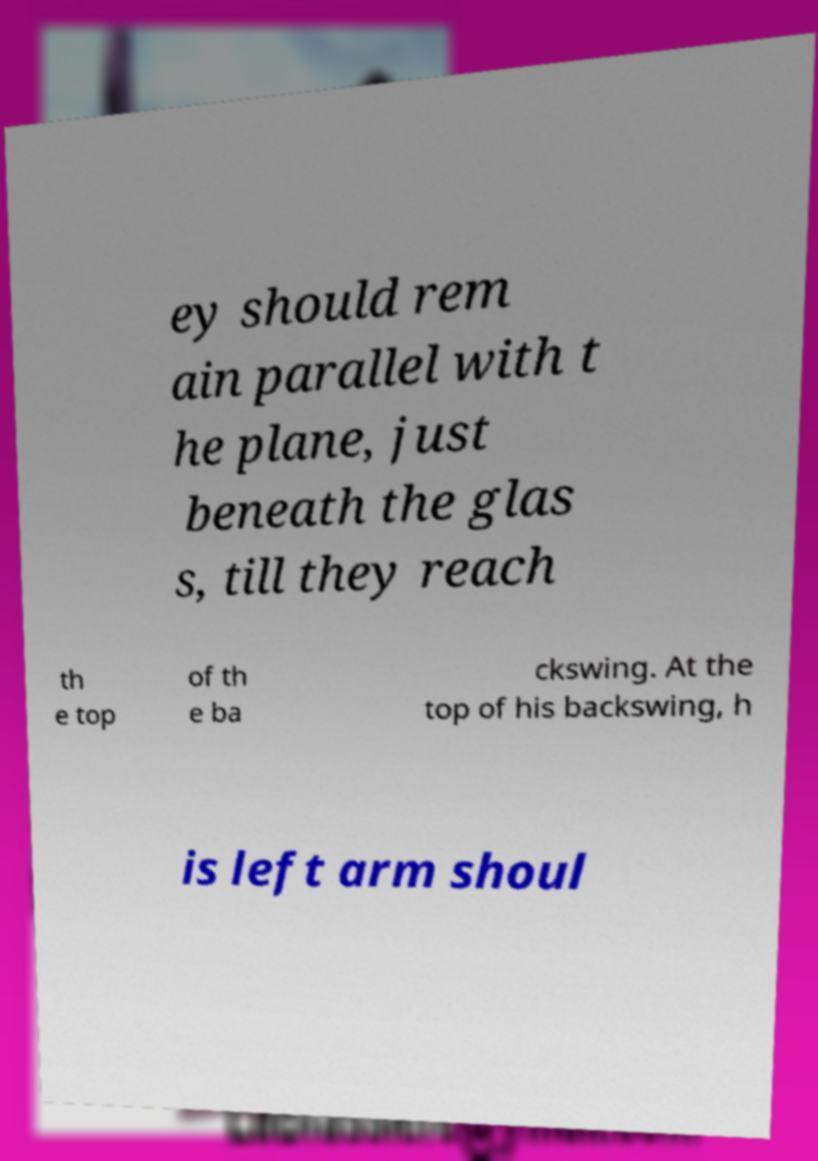Can you accurately transcribe the text from the provided image for me? ey should rem ain parallel with t he plane, just beneath the glas s, till they reach th e top of th e ba ckswing. At the top of his backswing, h is left arm shoul 